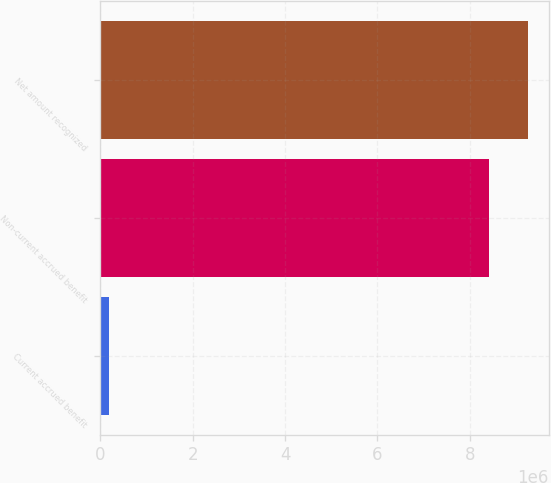Convert chart to OTSL. <chart><loc_0><loc_0><loc_500><loc_500><bar_chart><fcel>Current accrued benefit<fcel>Non-current accrued benefit<fcel>Net amount recognized<nl><fcel>183000<fcel>8.407e+06<fcel>9.2477e+06<nl></chart> 